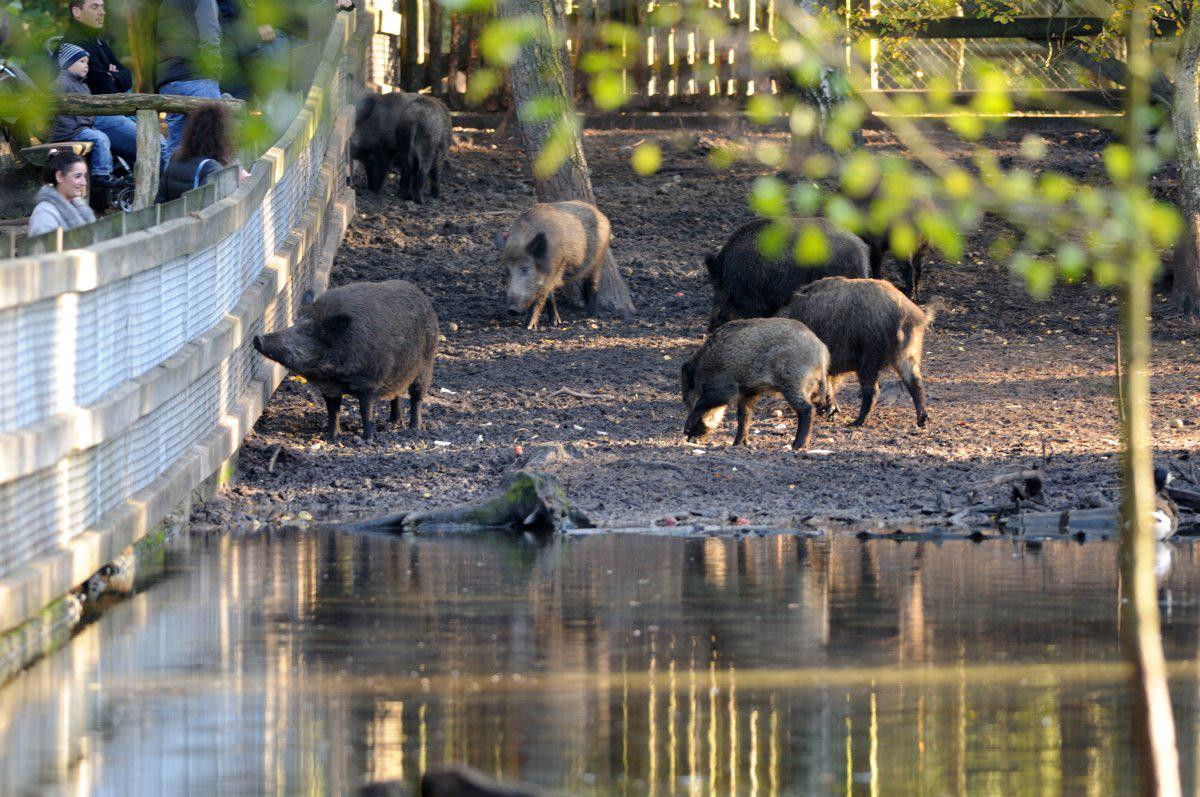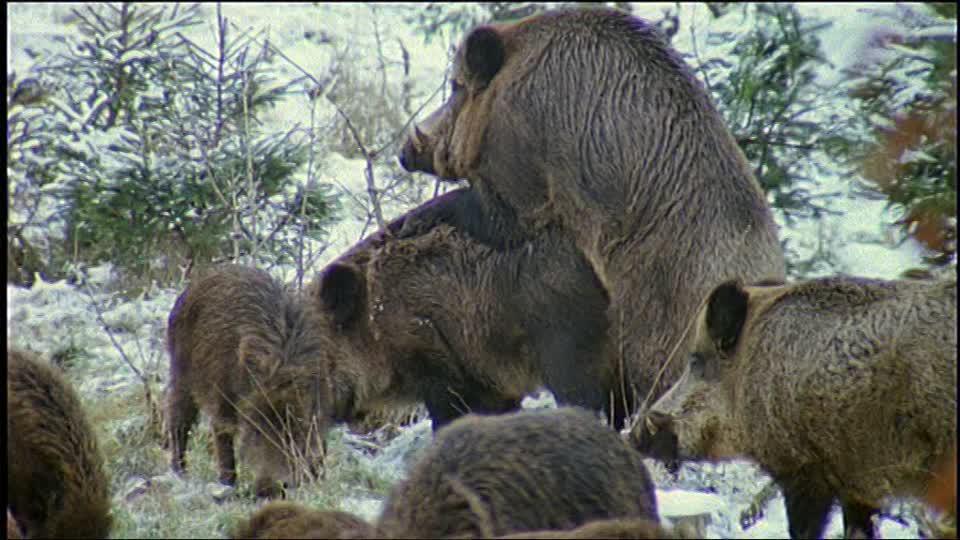The first image is the image on the left, the second image is the image on the right. For the images shown, is this caption "At least one man is standing behind a dead wild boar holding a gun." true? Answer yes or no. No. The first image is the image on the left, the second image is the image on the right. Analyze the images presented: Is the assertion "The right image contains a hunter posing with a dead boar." valid? Answer yes or no. No. 